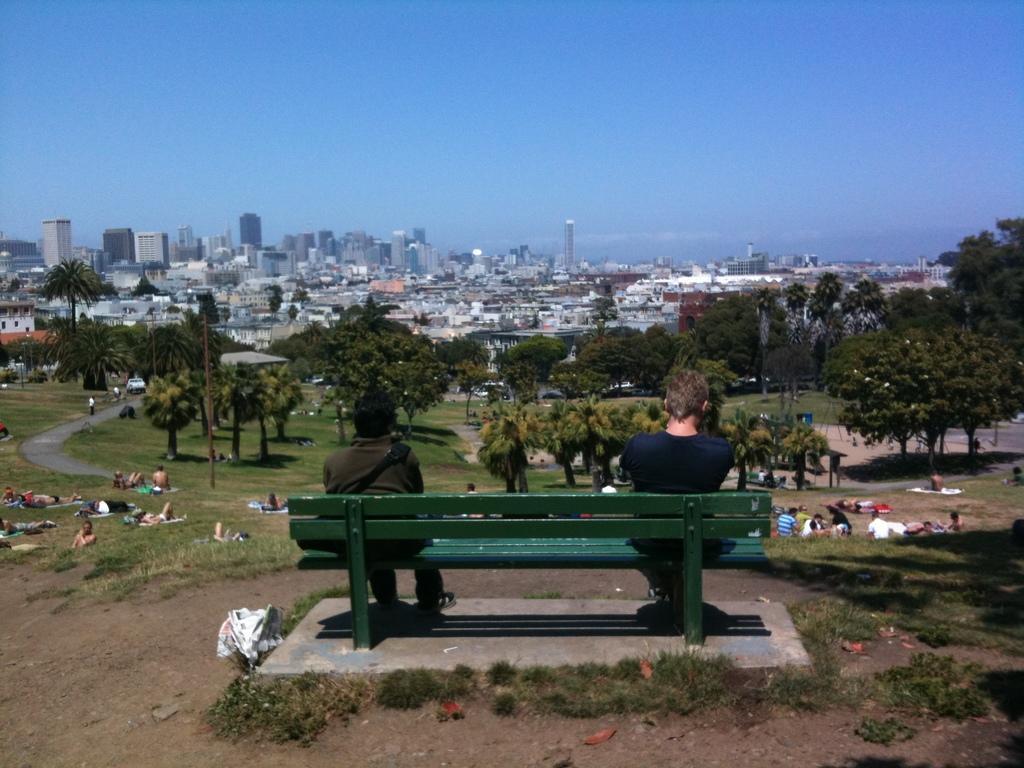Please provide a concise description of this image. There are two persons sitting in a green bench and there are group of people trees and buildings in front of them. 